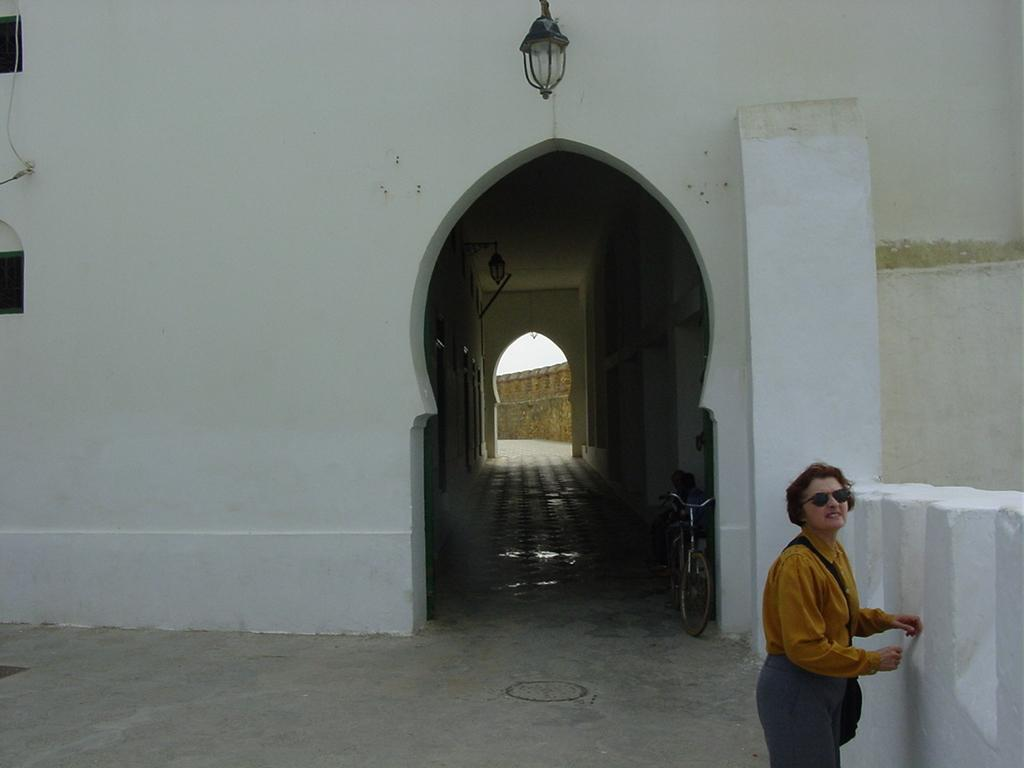What is the color of the building in the image? The building in the image is white. What mode of transportation can be seen in the image? There is a bicycle in the image. Who is present in the image? A woman is standing in the image. What is the woman carrying in the image? The woman is wearing a bag. What can be seen at the top of the image? There is a light visible at the top of the image. Where is the cow located in the image? There is no cow present in the image. What type of kettle can be seen in the image? There is no kettle present in the image. 